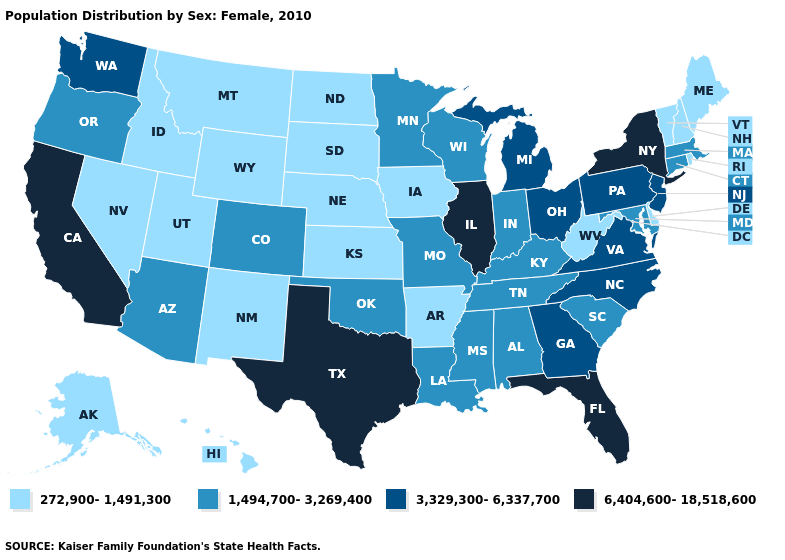Does Michigan have a lower value than Oregon?
Write a very short answer. No. What is the highest value in the USA?
Concise answer only. 6,404,600-18,518,600. Name the states that have a value in the range 272,900-1,491,300?
Keep it brief. Alaska, Arkansas, Delaware, Hawaii, Idaho, Iowa, Kansas, Maine, Montana, Nebraska, Nevada, New Hampshire, New Mexico, North Dakota, Rhode Island, South Dakota, Utah, Vermont, West Virginia, Wyoming. Which states have the lowest value in the USA?
Concise answer only. Alaska, Arkansas, Delaware, Hawaii, Idaho, Iowa, Kansas, Maine, Montana, Nebraska, Nevada, New Hampshire, New Mexico, North Dakota, Rhode Island, South Dakota, Utah, Vermont, West Virginia, Wyoming. Does Massachusetts have the highest value in the USA?
Answer briefly. No. Does Georgia have a lower value than North Carolina?
Be succinct. No. Name the states that have a value in the range 272,900-1,491,300?
Concise answer only. Alaska, Arkansas, Delaware, Hawaii, Idaho, Iowa, Kansas, Maine, Montana, Nebraska, Nevada, New Hampshire, New Mexico, North Dakota, Rhode Island, South Dakota, Utah, Vermont, West Virginia, Wyoming. How many symbols are there in the legend?
Short answer required. 4. Name the states that have a value in the range 1,494,700-3,269,400?
Give a very brief answer. Alabama, Arizona, Colorado, Connecticut, Indiana, Kentucky, Louisiana, Maryland, Massachusetts, Minnesota, Mississippi, Missouri, Oklahoma, Oregon, South Carolina, Tennessee, Wisconsin. What is the value of Indiana?
Be succinct. 1,494,700-3,269,400. Does Nebraska have the lowest value in the USA?
Short answer required. Yes. What is the value of Idaho?
Answer briefly. 272,900-1,491,300. Name the states that have a value in the range 3,329,300-6,337,700?
Quick response, please. Georgia, Michigan, New Jersey, North Carolina, Ohio, Pennsylvania, Virginia, Washington. What is the value of Wisconsin?
Short answer required. 1,494,700-3,269,400. Name the states that have a value in the range 6,404,600-18,518,600?
Write a very short answer. California, Florida, Illinois, New York, Texas. 